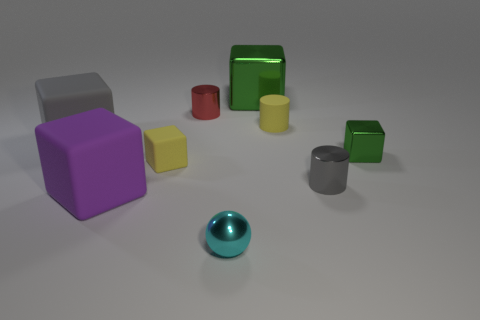What color is the other tiny rubber thing that is the same shape as the small green object? yellow 